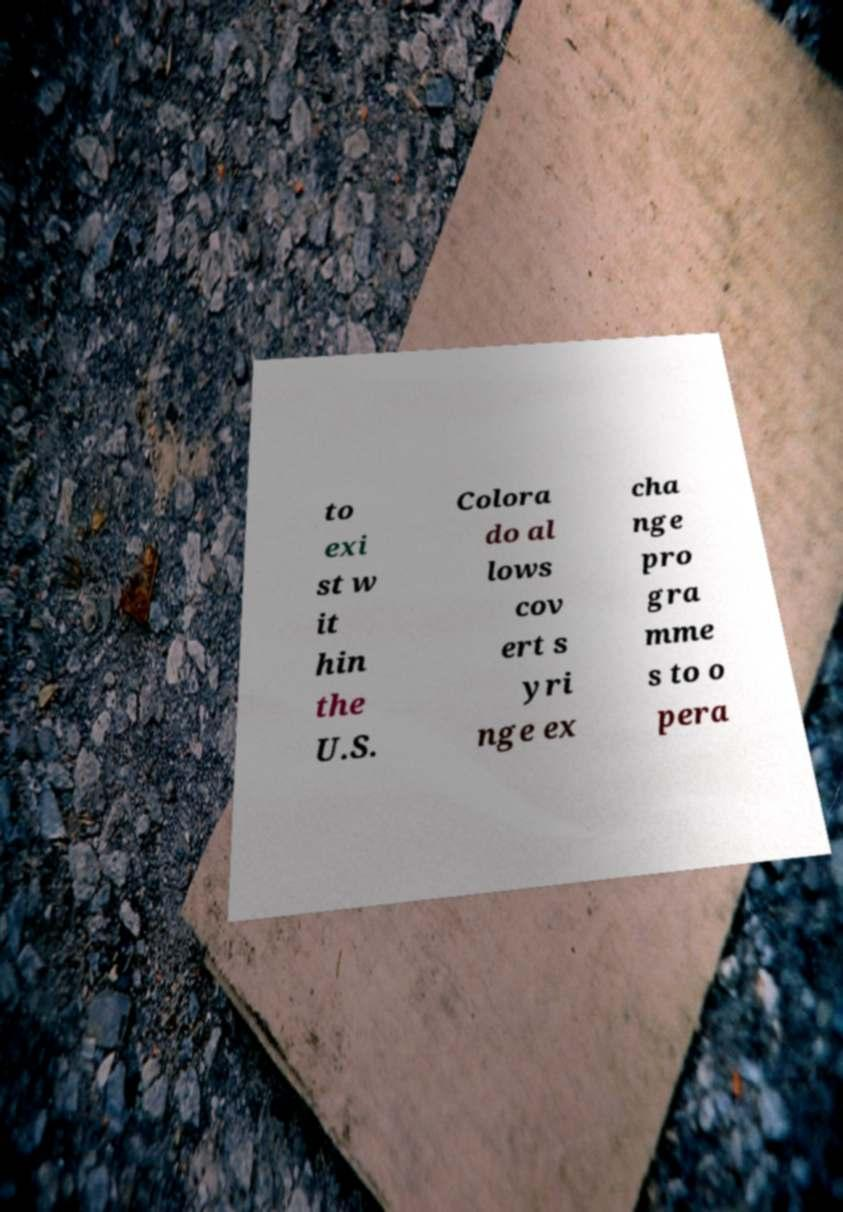What messages or text are displayed in this image? I need them in a readable, typed format. to exi st w it hin the U.S. Colora do al lows cov ert s yri nge ex cha nge pro gra mme s to o pera 